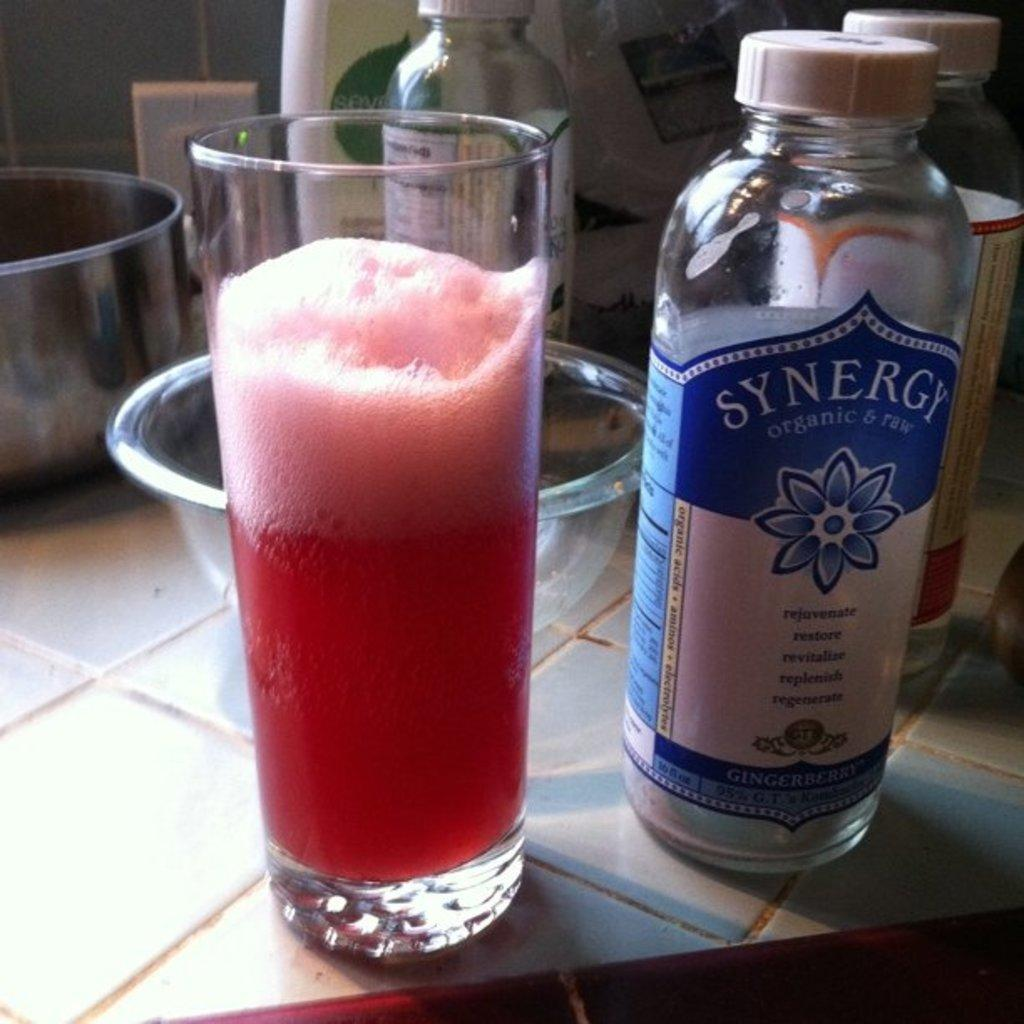<image>
Give a short and clear explanation of the subsequent image. A cup filled with a red drink next to a Synergy branded water bottle. 